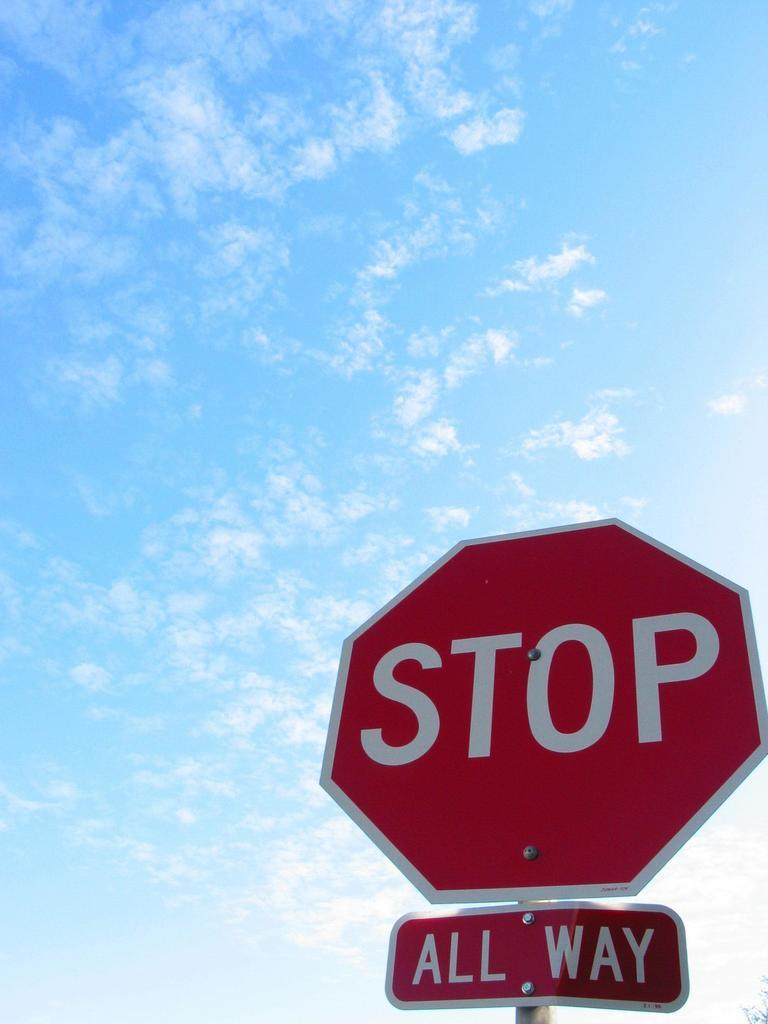<image>
Provide a brief description of the given image. A red stop sign under is says All way 